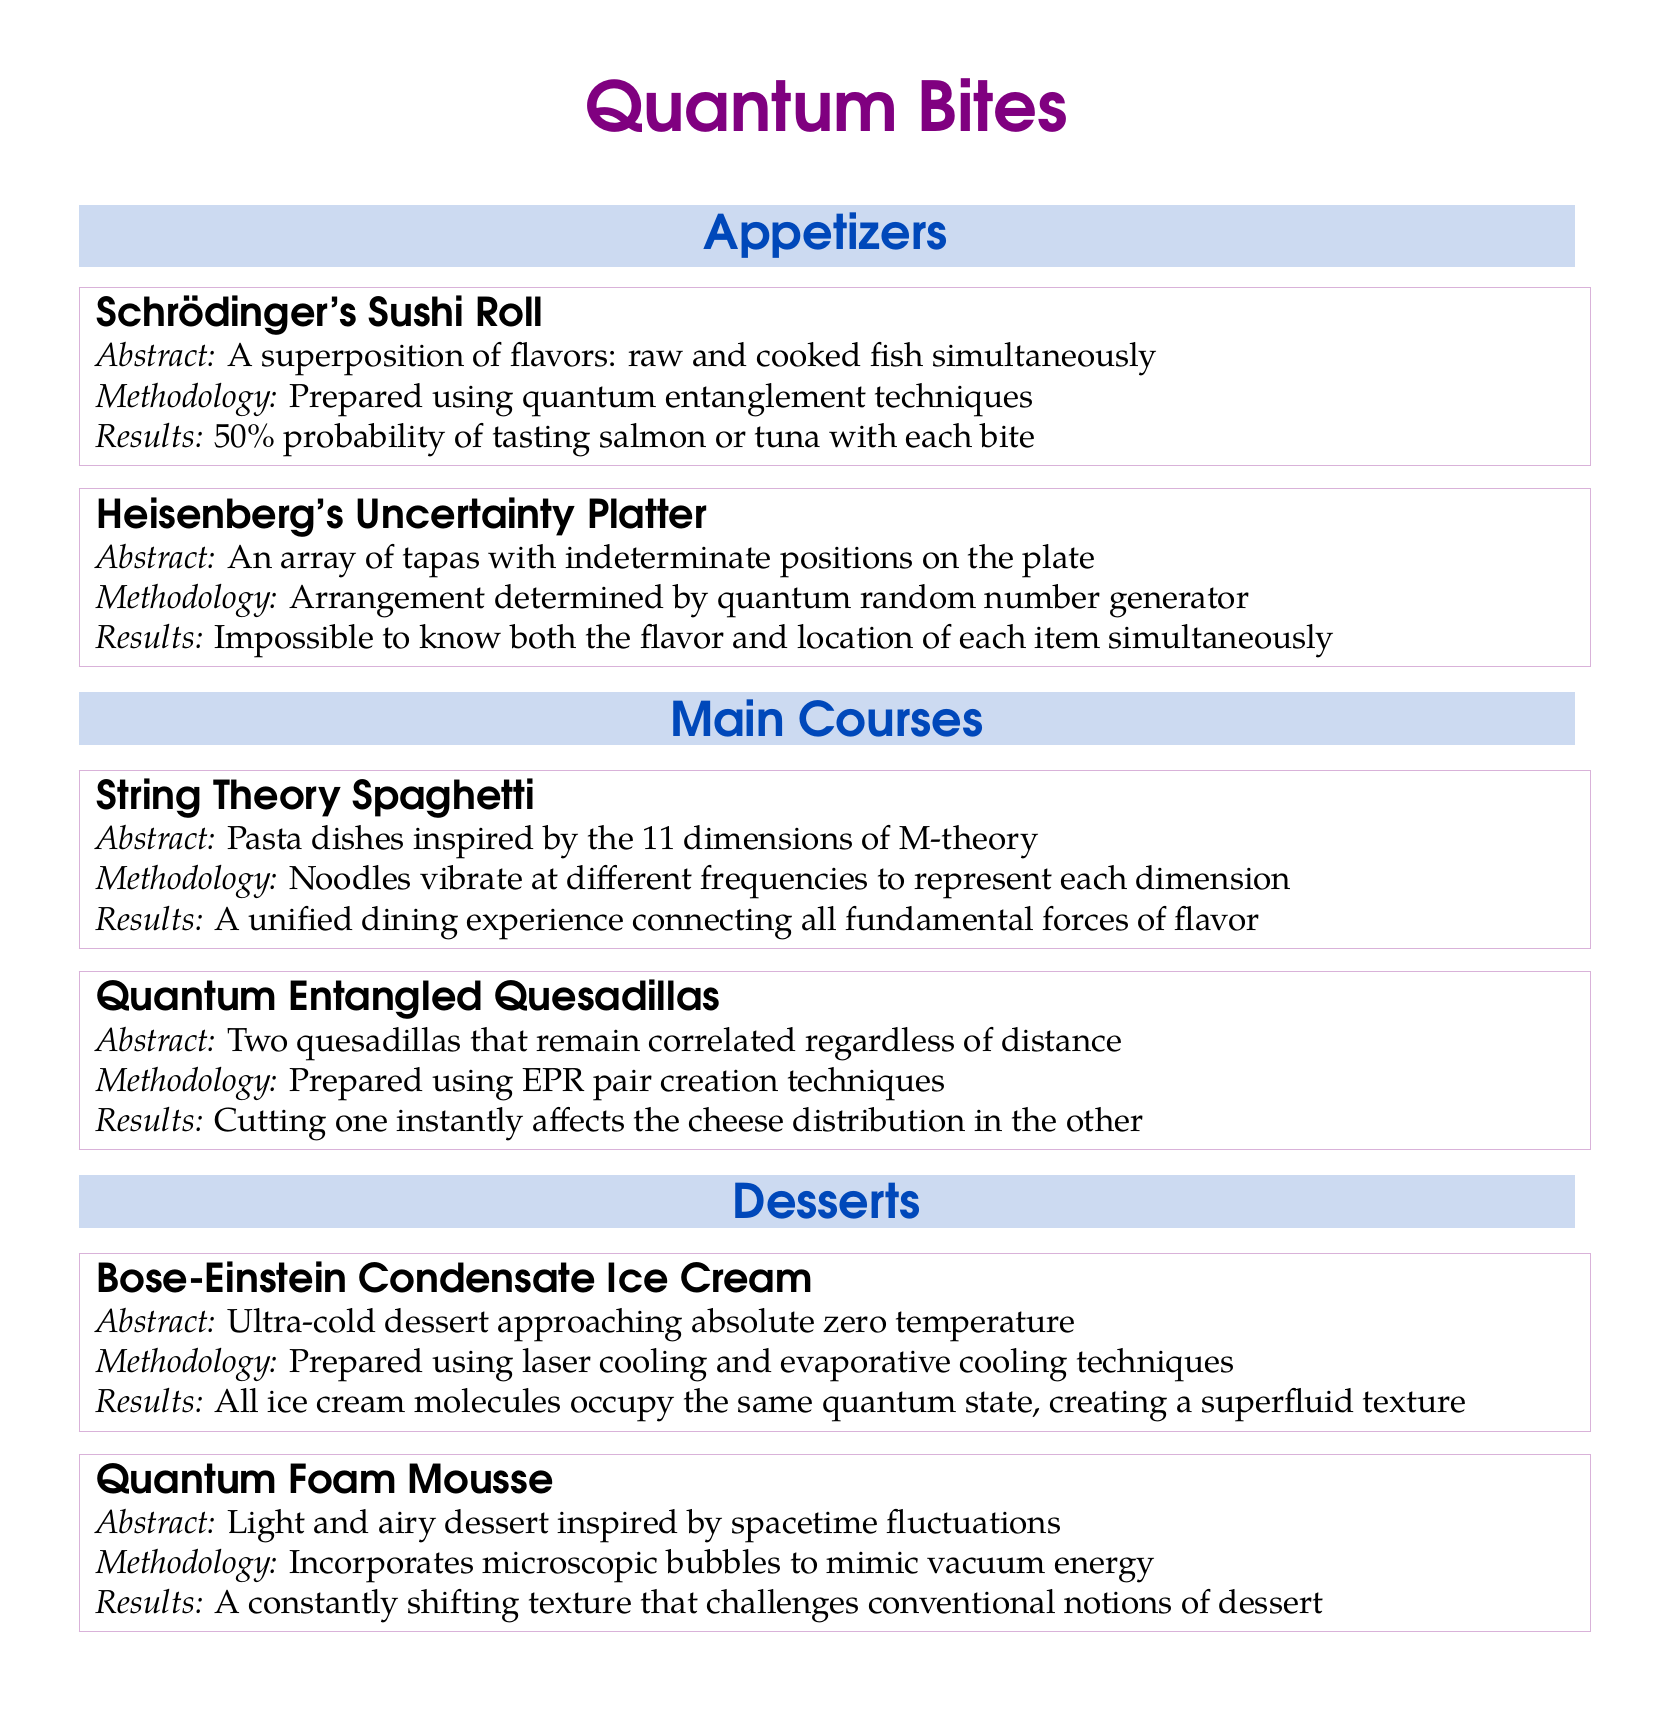What is the name of the first appetizer? The name of the first appetizer is "Schrödinger's Sushi Roll," which is listed in the Appetizers section.
Answer: Schrödinger's Sushi Roll What methodology is used for the Heisenberg's Uncertainty Platter? The methodology describes an arrangement determined by a quantum random number generator, as stated in the document.
Answer: Quantum random number generator How many dimensions inspire the String Theory Spaghetti? The document specifies that the String Theory Spaghetti is inspired by the 11 dimensions of M-theory.
Answer: 11 dimensions What is the main characteristic of the Bose-Einstein Condensate Ice Cream? The main characteristic described is that it approaches absolute zero temperature, according to the document.
Answer: Absolute zero temperature What affect does cutting one Quantum Entangled Quesadilla have? The document states that cutting one instantly affects the cheese distribution in the other, highlighting the correlation between the dishes.
Answer: Cheese distribution What type of dessert is the Quantum Foam Mousse inspired by? The document states that the Quantum Foam Mousse is inspired by spacetime fluctuations.
Answer: Spacetime fluctuations What is the abstract of Schrödinger's Sushi Roll? The abstract states it is "A superposition of flavors: raw and cooked fish simultaneously," as presented in the document.
Answer: A superposition of flavors: raw and cooked fish simultaneously How is the texture of the Bose-Einstein Condensate Ice Cream described? The document describes its texture as a superfluid texture, which results from all ice cream molecules occupying the same quantum state.
Answer: Superfluid texture What section contains the Quantum Entangled Quesadillas? The section containing the Quantum Entangled Quesadillas is the Main Courses section.
Answer: Main Courses 